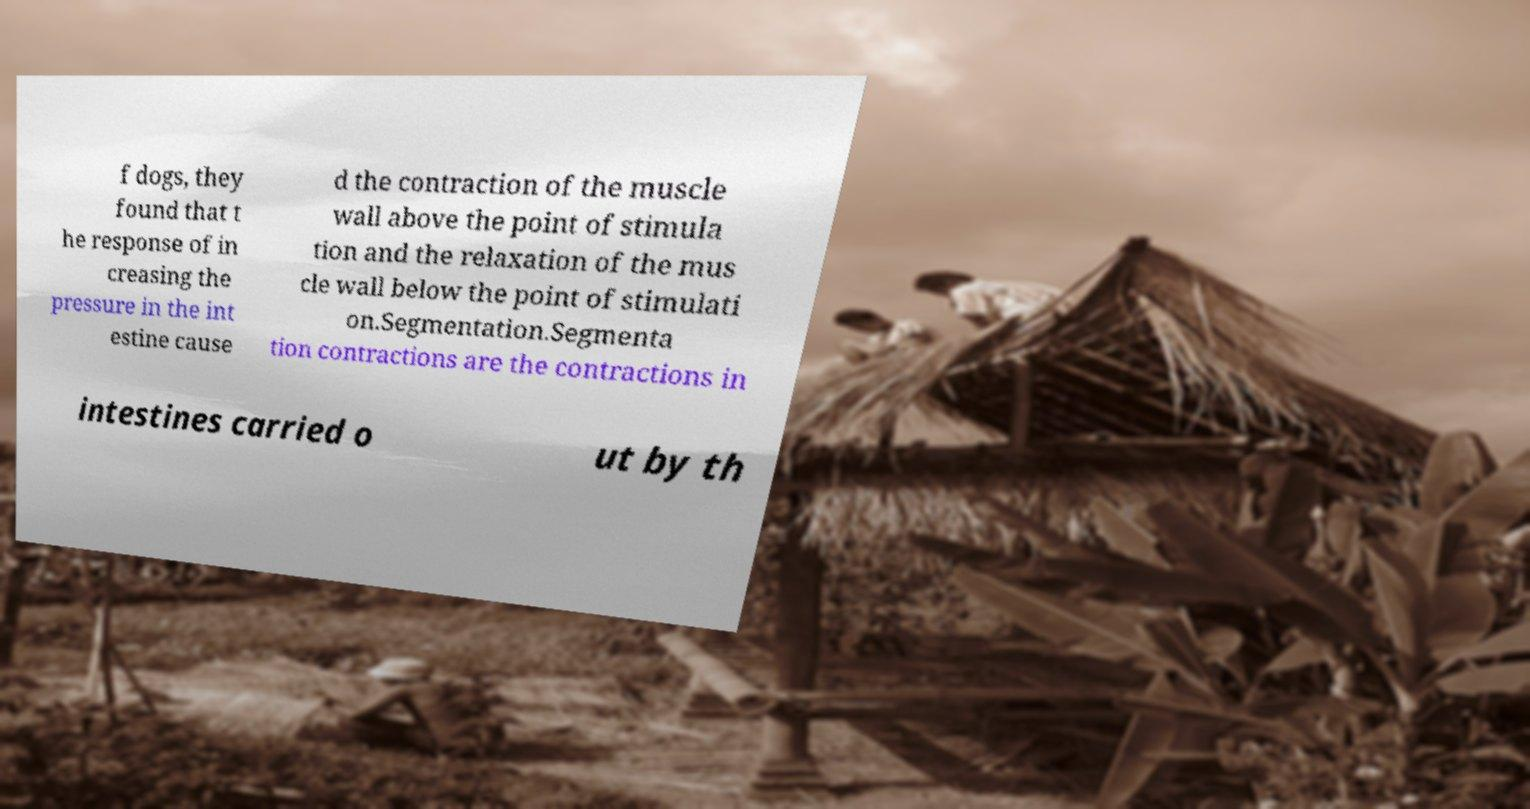For documentation purposes, I need the text within this image transcribed. Could you provide that? f dogs, they found that t he response of in creasing the pressure in the int estine cause d the contraction of the muscle wall above the point of stimula tion and the relaxation of the mus cle wall below the point of stimulati on.Segmentation.Segmenta tion contractions are the contractions in intestines carried o ut by th 